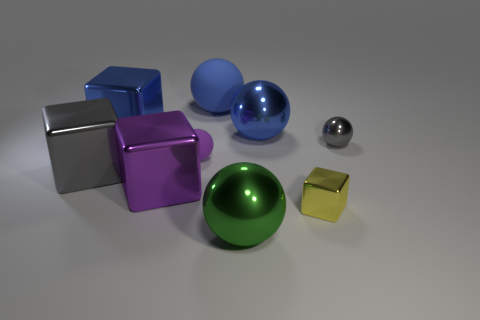Subtract all big blue blocks. How many blocks are left? 3 Subtract all blue balls. How many balls are left? 3 Subtract 3 cubes. How many cubes are left? 1 Subtract all small purple matte spheres. Subtract all blue shiny things. How many objects are left? 6 Add 4 tiny cubes. How many tiny cubes are left? 5 Add 1 small red metallic things. How many small red metallic things exist? 1 Add 1 yellow objects. How many objects exist? 10 Subtract 1 gray blocks. How many objects are left? 8 Subtract all spheres. How many objects are left? 4 Subtract all blue blocks. Subtract all green spheres. How many blocks are left? 3 